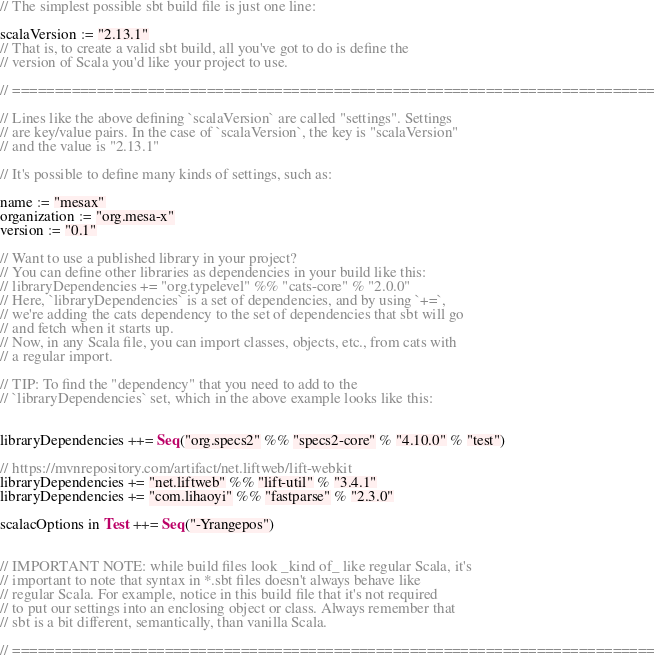<code> <loc_0><loc_0><loc_500><loc_500><_Scala_>
// The simplest possible sbt build file is just one line:

scalaVersion := "2.13.1"
// That is, to create a valid sbt build, all you've got to do is define the
// version of Scala you'd like your project to use.

// ============================================================================

// Lines like the above defining `scalaVersion` are called "settings". Settings
// are key/value pairs. In the case of `scalaVersion`, the key is "scalaVersion"
// and the value is "2.13.1"

// It's possible to define many kinds of settings, such as:

name := "mesax"
organization := "org.mesa-x"
version := "0.1"

// Want to use a published library in your project?
// You can define other libraries as dependencies in your build like this:
// libraryDependencies += "org.typelevel" %% "cats-core" % "2.0.0"
// Here, `libraryDependencies` is a set of dependencies, and by using `+=`,
// we're adding the cats dependency to the set of dependencies that sbt will go
// and fetch when it starts up.
// Now, in any Scala file, you can import classes, objects, etc., from cats with
// a regular import.

// TIP: To find the "dependency" that you need to add to the
// `libraryDependencies` set, which in the above example looks like this:


libraryDependencies ++= Seq("org.specs2" %% "specs2-core" % "4.10.0" % "test")

// https://mvnrepository.com/artifact/net.liftweb/lift-webkit
libraryDependencies += "net.liftweb" %% "lift-util" % "3.4.1"
libraryDependencies += "com.lihaoyi" %% "fastparse" % "2.3.0"

scalacOptions in Test ++= Seq("-Yrangepos")


// IMPORTANT NOTE: while build files look _kind of_ like regular Scala, it's
// important to note that syntax in *.sbt files doesn't always behave like
// regular Scala. For example, notice in this build file that it's not required
// to put our settings into an enclosing object or class. Always remember that
// sbt is a bit different, semantically, than vanilla Scala.

// ============================================================================

</code> 